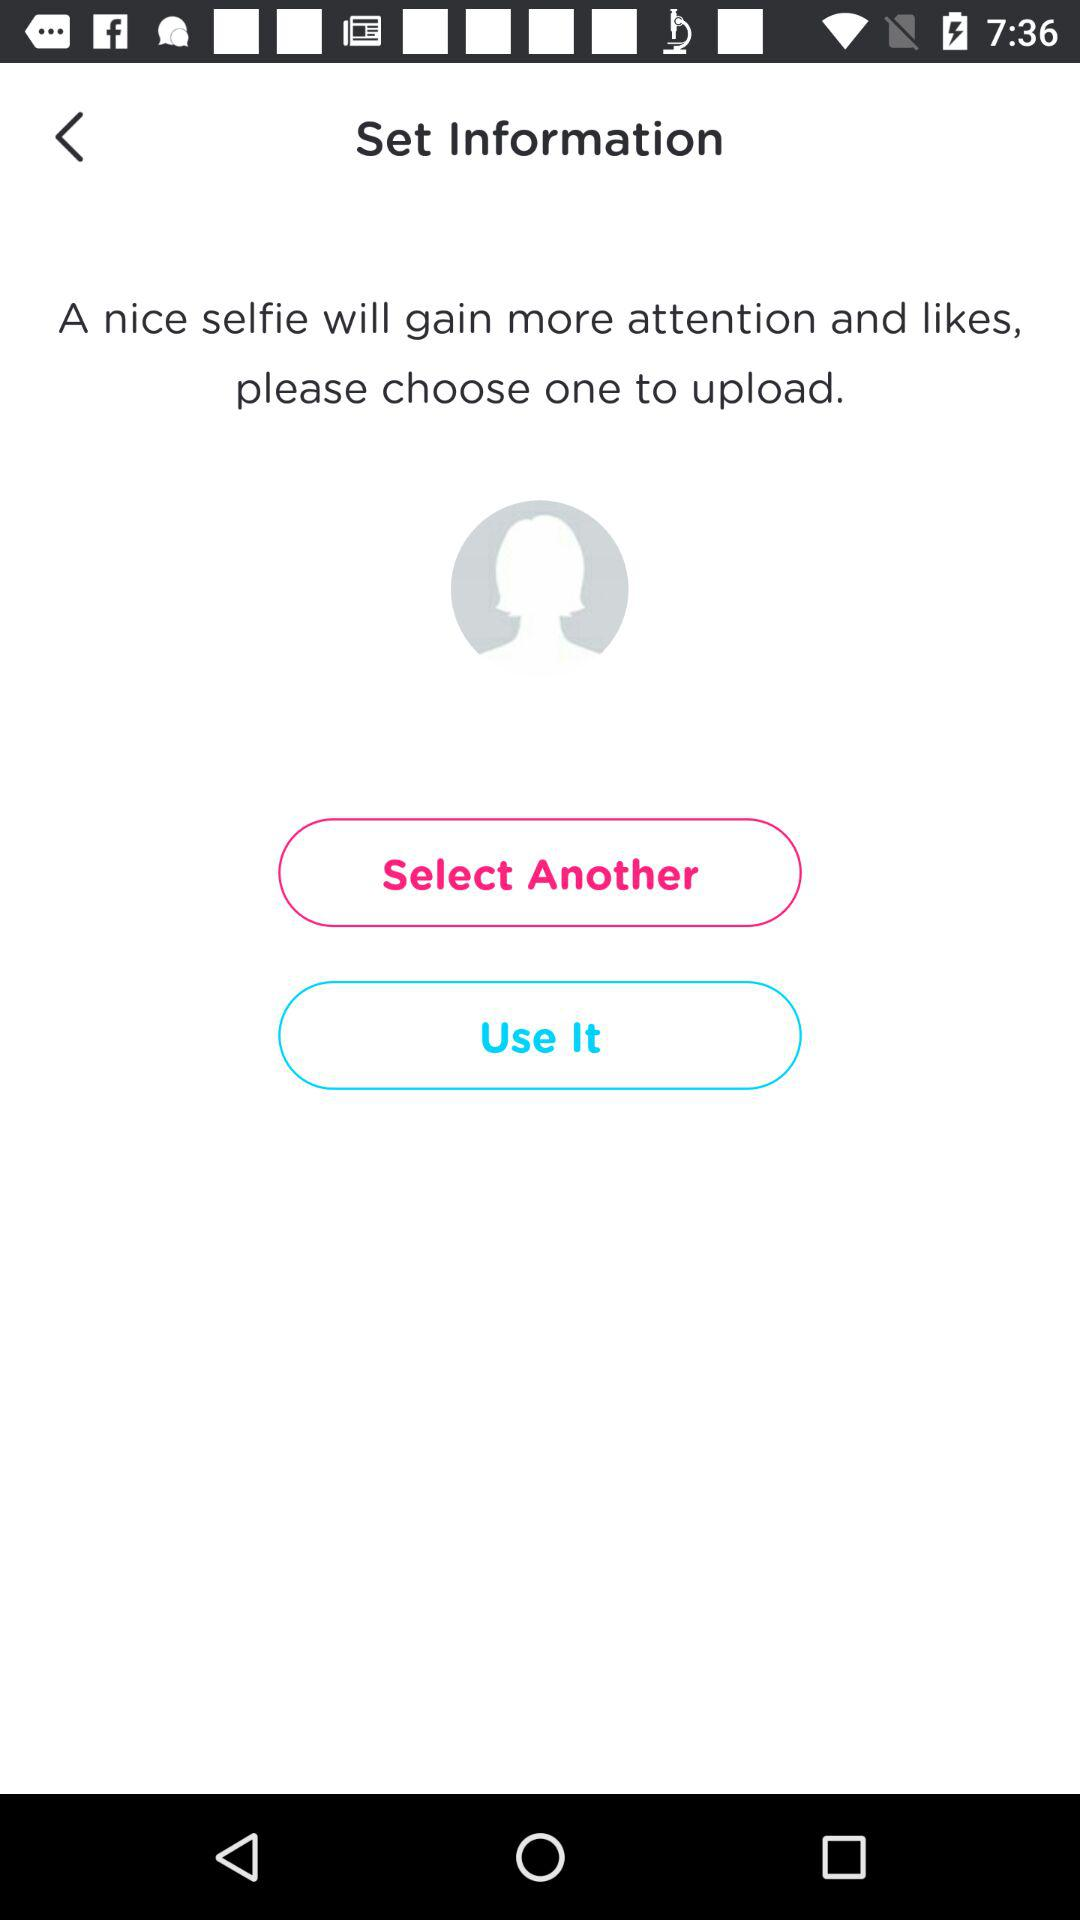What will a nice selfie gain? A nice selfie will gain more attention and likes. 